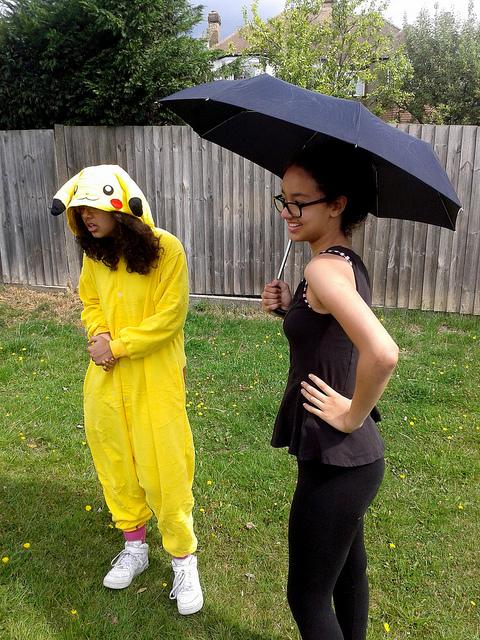Is raining?
Write a very short answer. No. What is the woman in yellow wearing on her head?
Give a very brief answer. Hood. Are there flowers in the grass?
Short answer required. Yes. 